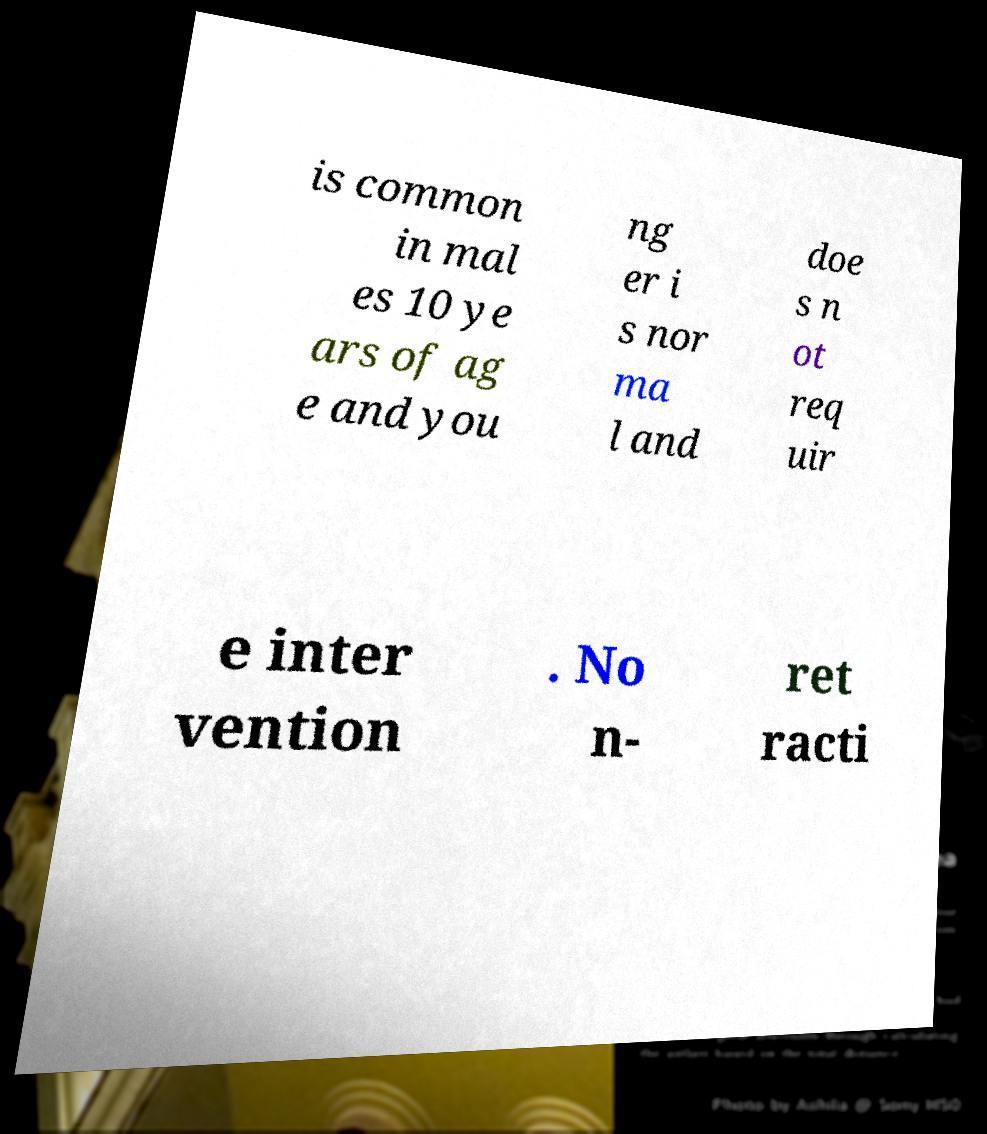Could you assist in decoding the text presented in this image and type it out clearly? is common in mal es 10 ye ars of ag e and you ng er i s nor ma l and doe s n ot req uir e inter vention . No n- ret racti 